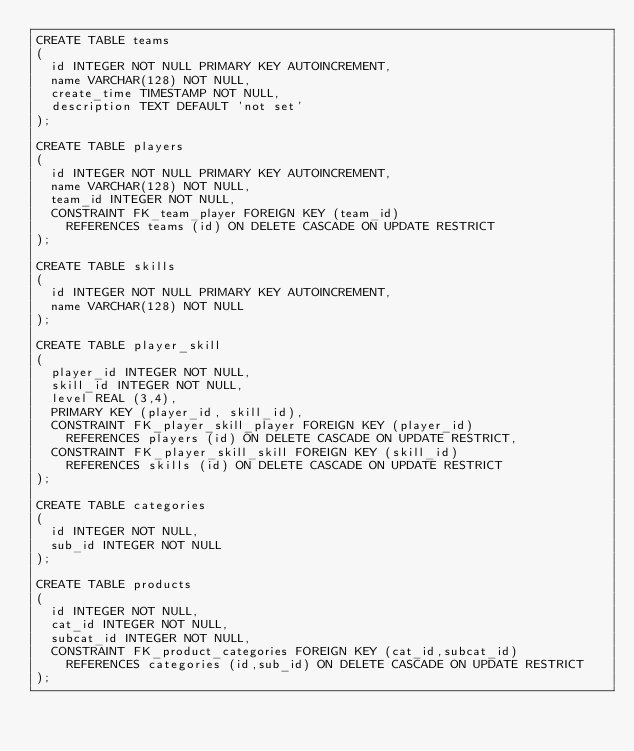<code> <loc_0><loc_0><loc_500><loc_500><_SQL_>CREATE TABLE teams
(
	id INTEGER NOT NULL PRIMARY KEY AUTOINCREMENT,
	name VARCHAR(128) NOT NULL,
	create_time TIMESTAMP NOT NULL,
	description TEXT DEFAULT 'not set'
);

CREATE TABLE players
(
	id INTEGER NOT NULL PRIMARY KEY AUTOINCREMENT,
	name VARCHAR(128) NOT NULL,
	team_id INTEGER NOT NULL,
	CONSTRAINT FK_team_player FOREIGN KEY (team_id)
		REFERENCES teams (id) ON DELETE CASCADE ON UPDATE RESTRICT
);

CREATE TABLE skills
(
	id INTEGER NOT NULL PRIMARY KEY AUTOINCREMENT,
	name VARCHAR(128) NOT NULL
);

CREATE TABLE player_skill
(
	player_id INTEGER NOT NULL,
	skill_id INTEGER NOT NULL,
	level REAL (3,4),
	PRIMARY KEY (player_id, skill_id),
	CONSTRAINT FK_player_skill_player FOREIGN KEY (player_id)
		REFERENCES players (id) ON DELETE CASCADE ON UPDATE RESTRICT,
	CONSTRAINT FK_player_skill_skill FOREIGN KEY (skill_id)
		REFERENCES skills (id) ON DELETE CASCADE ON UPDATE RESTRICT
);

CREATE TABLE categories
(
	id INTEGER NOT NULL,
	sub_id INTEGER NOT NULL
);

CREATE TABLE products
(
	id INTEGER NOT NULL,
	cat_id INTEGER NOT NULL,
	subcat_id INTEGER NOT NULL,
	CONSTRAINT FK_product_categories FOREIGN KEY (cat_id,subcat_id)
		REFERENCES categories (id,sub_id) ON DELETE CASCADE ON UPDATE RESTRICT
);</code> 